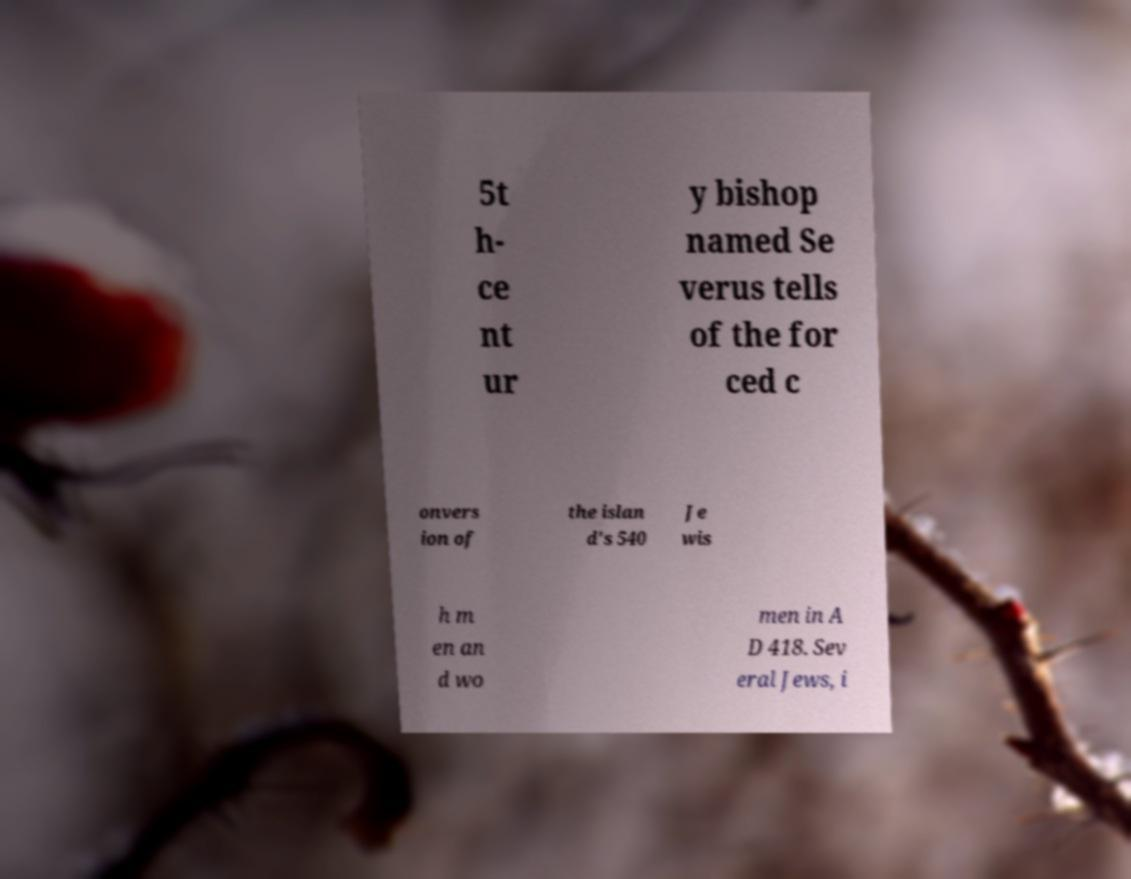Please identify and transcribe the text found in this image. 5t h- ce nt ur y bishop named Se verus tells of the for ced c onvers ion of the islan d's 540 Je wis h m en an d wo men in A D 418. Sev eral Jews, i 